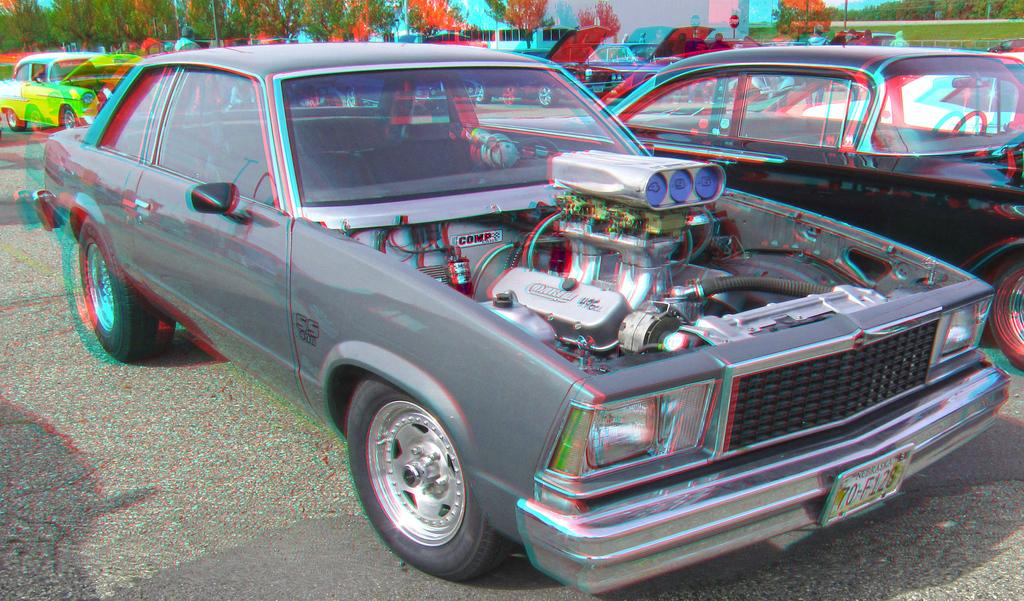What can be inferred about the image based on the first fact? The image appears to be edited, which means it might have been altered or manipulated in some way. What can be seen on the ground in the image? There are cars parked in the image. What object resembles a part of a vehicle in the image? There is an object that resembles an engine in the image. What type of natural environment is visible in the background of the image? There are trees in the background of the image. What type of structure is visible in the background of the image? There is a building in the background of the image. What type of rock is being used as a stage prop in the image? There is no rock present in the image; it features cars, an engine-like object, and background elements. 